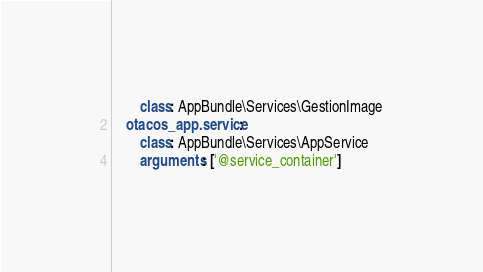Convert code to text. <code><loc_0><loc_0><loc_500><loc_500><_YAML_>        class: AppBundle\Services\GestionImage
    otacos_app.service:
        class: AppBundle\Services\AppService
        arguments: ['@service_container']</code> 